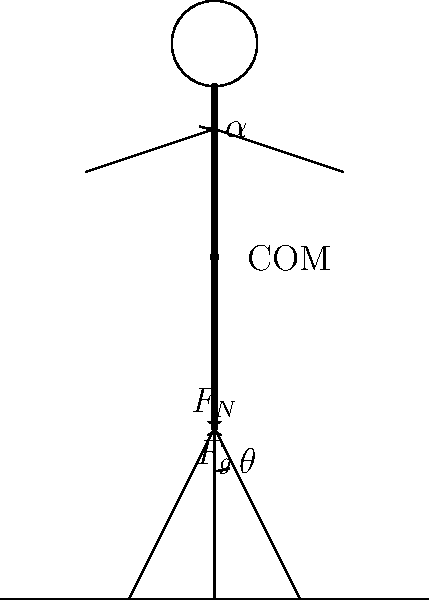During community events, you often find yourself standing for extended periods. Consider the biomechanics of maintaining an upright posture. If the center of mass (COM) of your body is located at 60% of your total height from the ground, and you're leaning slightly forward at an angle $\theta$ of 10° from vertical, what angle $\alpha$ should your head be tilted back to maintain a balanced posture? To maintain balance while standing, we need to ensure that the center of mass (COM) remains directly above the base of support. Let's approach this step-by-step:

1. In a perfectly upright posture, the COM would be aligned vertically above the feet.

2. When leaning forward by an angle $\theta$, the COM shifts forward, potentially causing imbalance.

3. To counteract this, we need to shift the upper body (primarily the head) backwards.

4. The goal is to keep the COM in the same vertical line as in the upright position.

5. We can think of this as a see-saw around the hip joint, with the COM as the pivot point.

6. The portion of the body below the COM (60% of height) is leaning forward by $\theta = 10°$.

7. The remaining 40% of the body (above the COM) needs to compensate by leaning backward.

8. To calculate the required angle $\alpha$, we can use the principle of moments:

   $0.6h \cdot \sin(\theta) = 0.4h \cdot \sin(\alpha)$

   Where $h$ is the total height (which cancels out).

9. Rearranging the equation:

   $\sin(\alpha) = \frac{0.6 \cdot \sin(10°)}{0.4}$

10. Solving for $\alpha$:

    $\alpha = \arcsin(\frac{0.6 \cdot \sin(10°)}{0.4}) \approx 15.3°$

Therefore, to maintain balance, the head should be tilted back by approximately 15.3° relative to the vertical.
Answer: $\alpha \approx 15.3°$ 